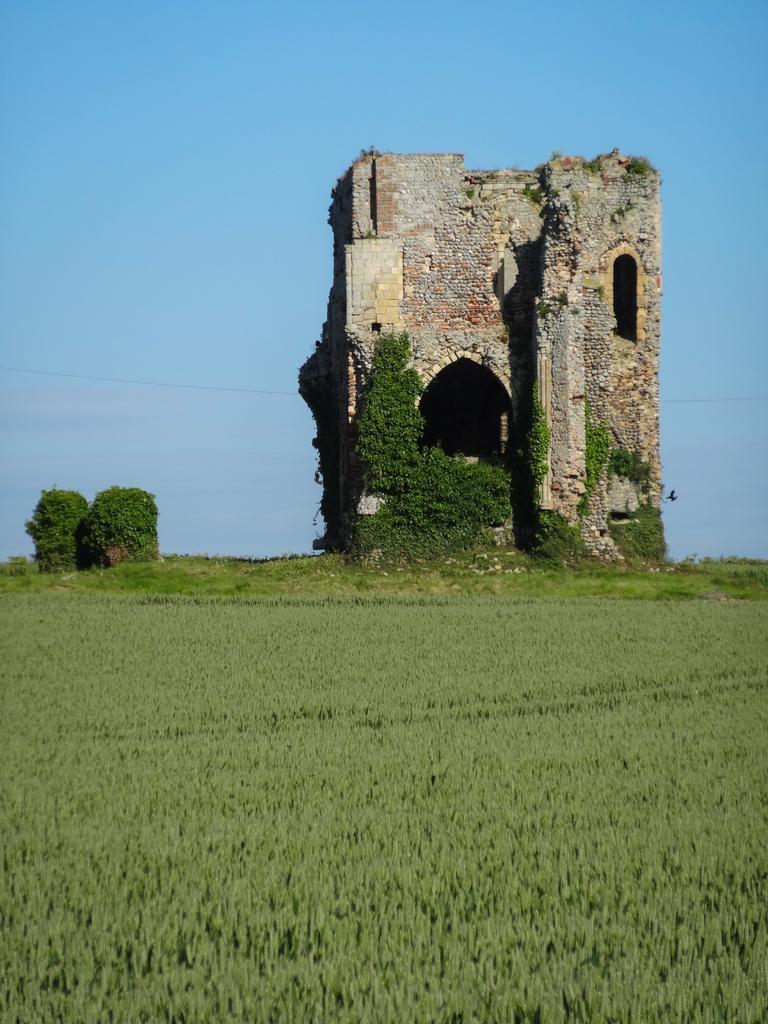Can you describe this image briefly? In this image we can see a building. We can also see some plants, trees, wire, a bird and the sky which looks cloudy. 